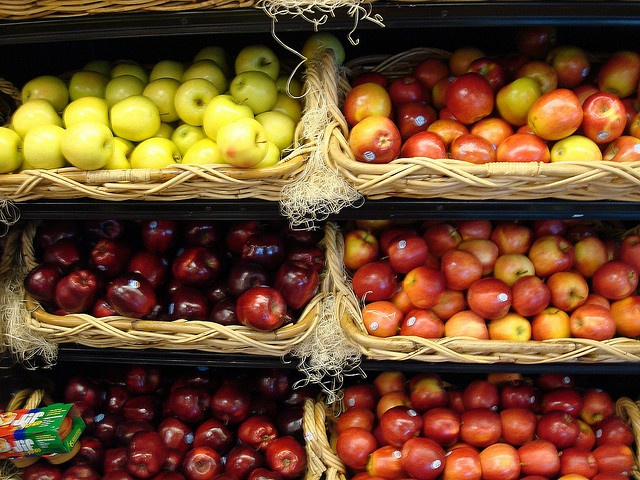Describe the objects in this image and their specific colors. I can see apple in brown, black, and maroon tones, apple in brown, black, and maroon tones, apple in brown, red, and orange tones, apple in brown, maroon, and black tones, and apple in brown and maroon tones in this image. 